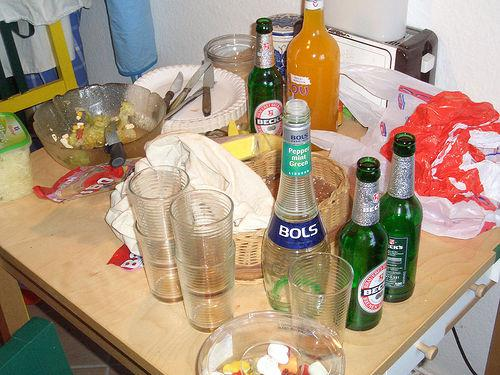Question: what color are the cups?
Choices:
A. Clear.
B. Black.
C. Brown.
D. Red.
Answer with the letter. Answer: A Question: what color is the drawer?
Choices:
A. Brown.
B. Tan.
C. White.
D. Red.
Answer with the letter. Answer: C Question: what is orange?
Choices:
A. Carrot.
B. Fruit.
C. Bottle.
D. Painting.
Answer with the letter. Answer: C Question: how many cups are shown?
Choices:
A. One.
B. Five.
C. Two.
D. Three.
Answer with the letter. Answer: B Question: where are the cups?
Choices:
A. In the cabinet.
B. In the dishwasher.
C. On the counter.
D. Table.
Answer with the letter. Answer: D Question: what type of plates are shown?
Choices:
A. Plastic.
B. Paper.
C. Porcelain.
D. Wooden.
Answer with the letter. Answer: B Question: what type of table is shown?
Choices:
A. Plastic.
B. Wooden.
C. Metal.
D. Wicker.
Answer with the letter. Answer: B 